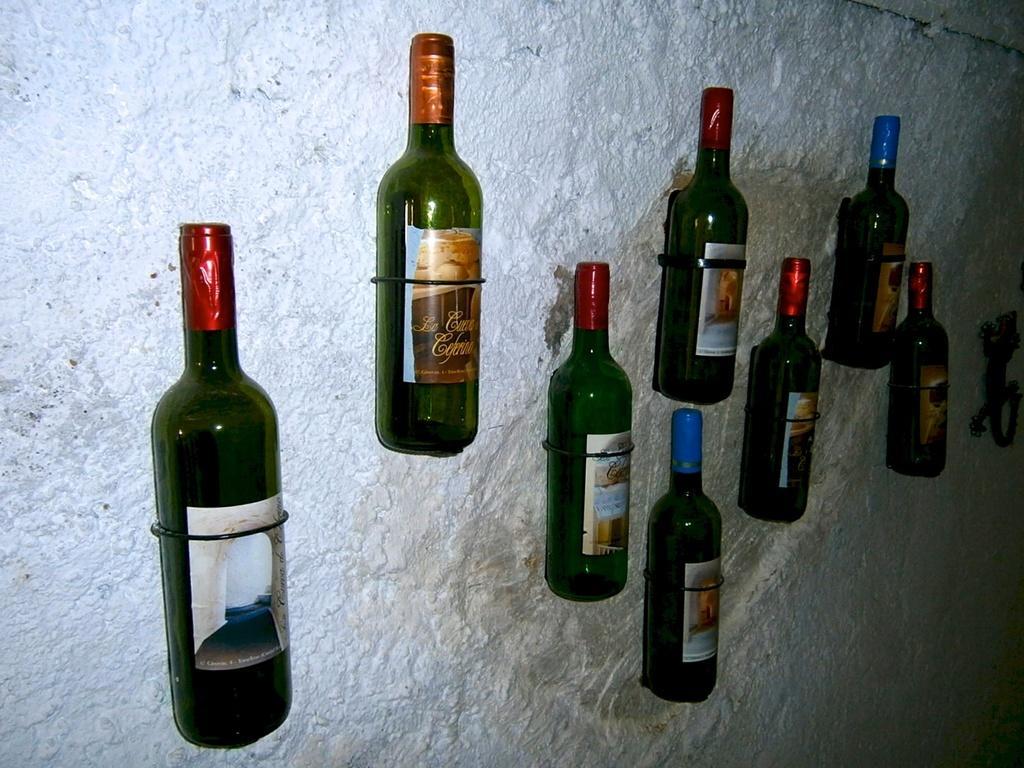Could you give a brief overview of what you see in this image? In this image i can see few bottles attached to a wall. 